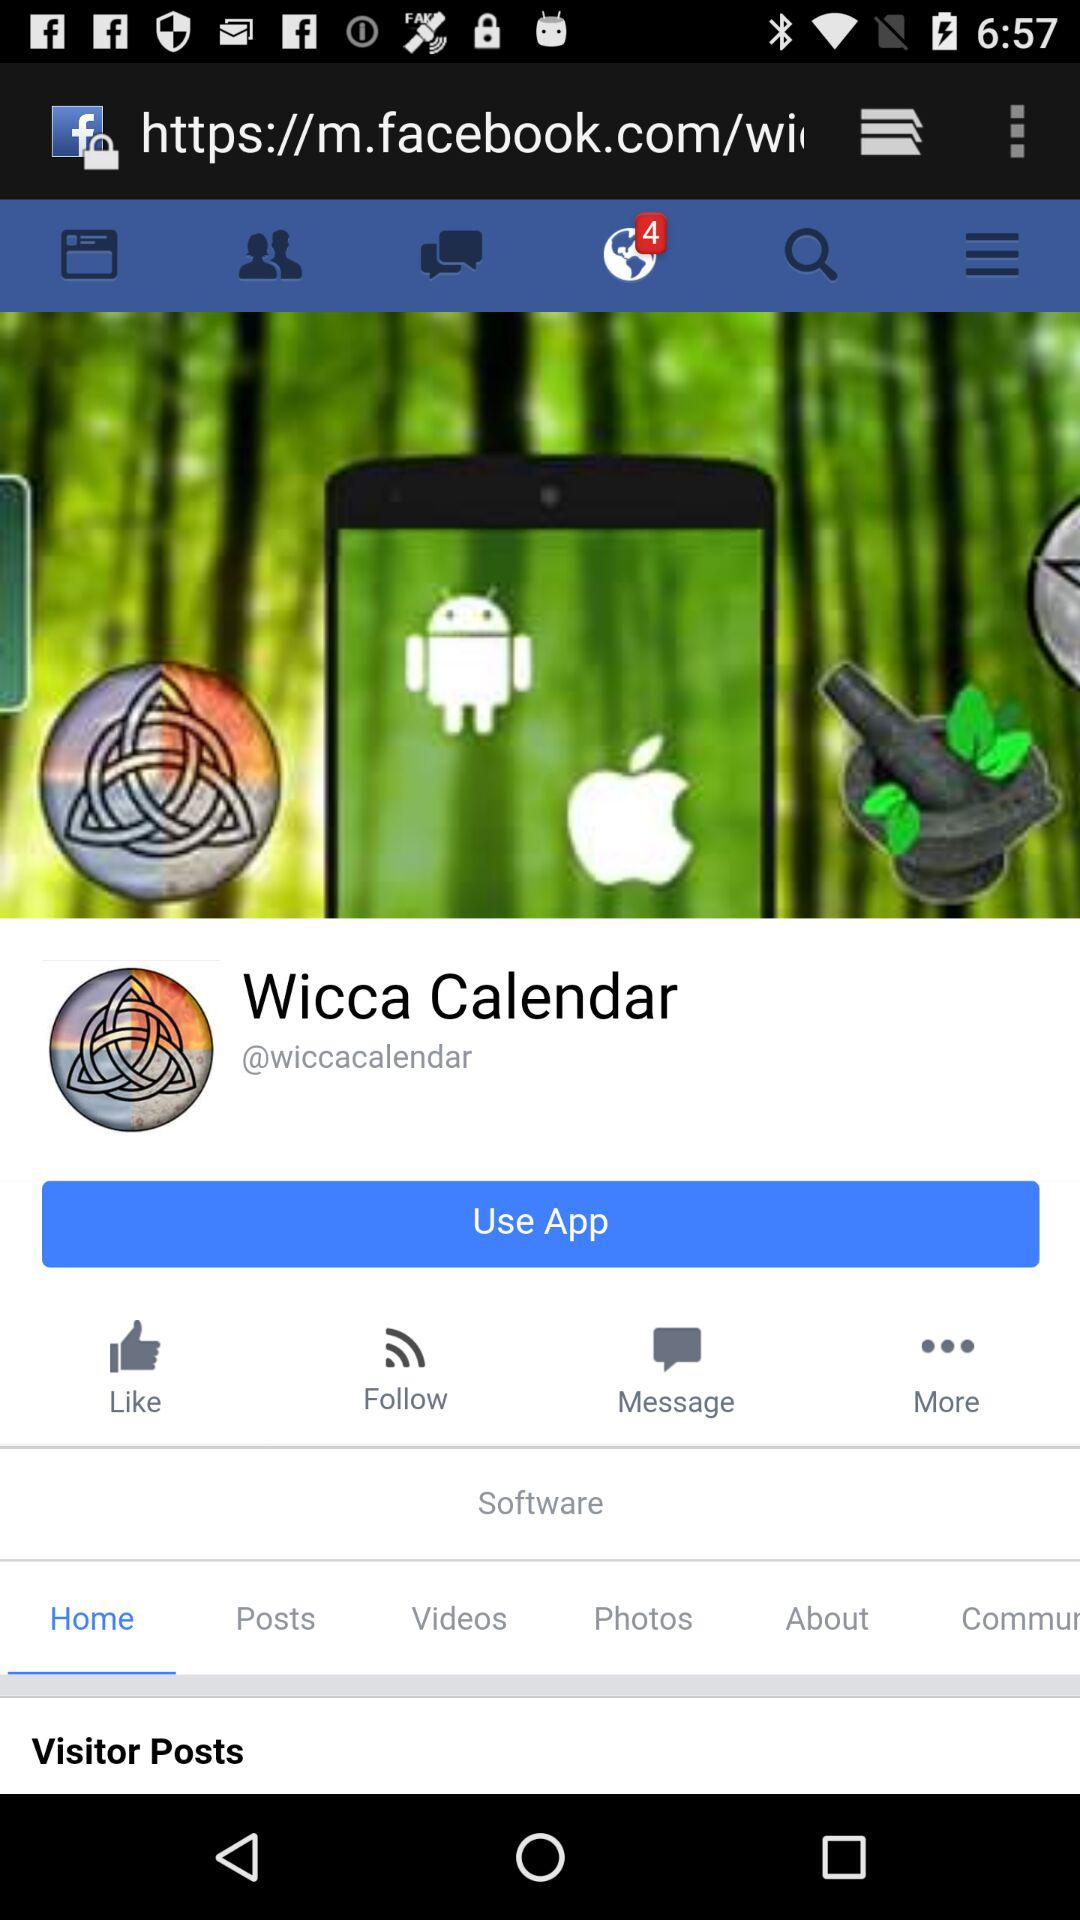What is the selected tab? The selected tab is "Home". 